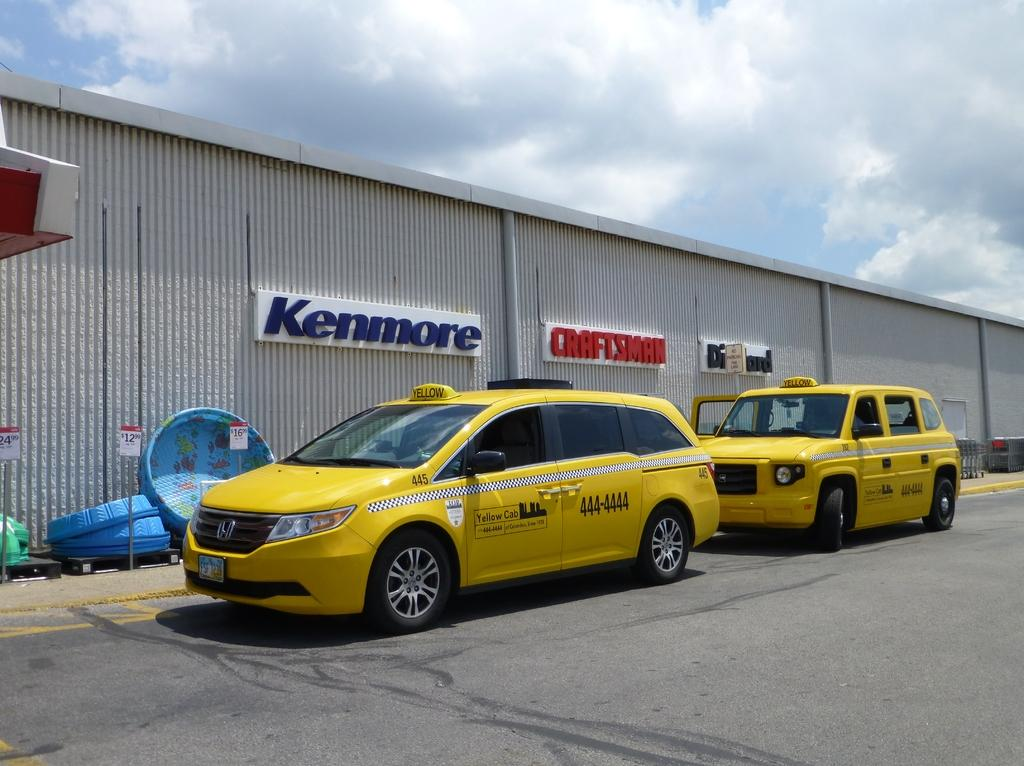<image>
Give a short and clear explanation of the subsequent image. a building that has a kenmore sign on it 